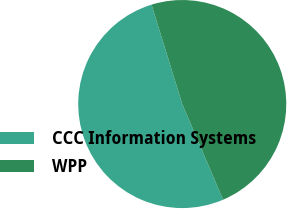<chart> <loc_0><loc_0><loc_500><loc_500><pie_chart><fcel>CCC Information Systems<fcel>WPP<nl><fcel>51.66%<fcel>48.34%<nl></chart> 